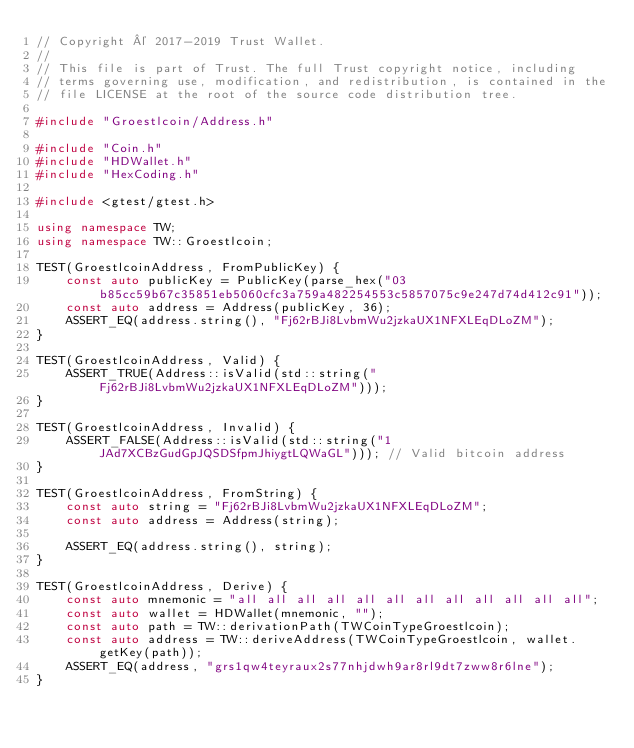<code> <loc_0><loc_0><loc_500><loc_500><_C++_>// Copyright © 2017-2019 Trust Wallet.
//
// This file is part of Trust. The full Trust copyright notice, including
// terms governing use, modification, and redistribution, is contained in the
// file LICENSE at the root of the source code distribution tree.

#include "Groestlcoin/Address.h"

#include "Coin.h"
#include "HDWallet.h"
#include "HexCoding.h"

#include <gtest/gtest.h>

using namespace TW;
using namespace TW::Groestlcoin;

TEST(GroestlcoinAddress, FromPublicKey) {
    const auto publicKey = PublicKey(parse_hex("03b85cc59b67c35851eb5060cfc3a759a482254553c5857075c9e247d74d412c91"));
    const auto address = Address(publicKey, 36);
    ASSERT_EQ(address.string(), "Fj62rBJi8LvbmWu2jzkaUX1NFXLEqDLoZM");
}

TEST(GroestlcoinAddress, Valid) {
    ASSERT_TRUE(Address::isValid(std::string("Fj62rBJi8LvbmWu2jzkaUX1NFXLEqDLoZM")));
}

TEST(GroestlcoinAddress, Invalid) {
    ASSERT_FALSE(Address::isValid(std::string("1JAd7XCBzGudGpJQSDSfpmJhiygtLQWaGL"))); // Valid bitcoin address
}

TEST(GroestlcoinAddress, FromString) {
    const auto string = "Fj62rBJi8LvbmWu2jzkaUX1NFXLEqDLoZM";
    const auto address = Address(string);

    ASSERT_EQ(address.string(), string);
}

TEST(GroestlcoinAddress, Derive) {
    const auto mnemonic = "all all all all all all all all all all all all";
    const auto wallet = HDWallet(mnemonic, "");
    const auto path = TW::derivationPath(TWCoinTypeGroestlcoin);
    const auto address = TW::deriveAddress(TWCoinTypeGroestlcoin, wallet.getKey(path));
    ASSERT_EQ(address, "grs1qw4teyraux2s77nhjdwh9ar8rl9dt7zww8r6lne");
}
</code> 